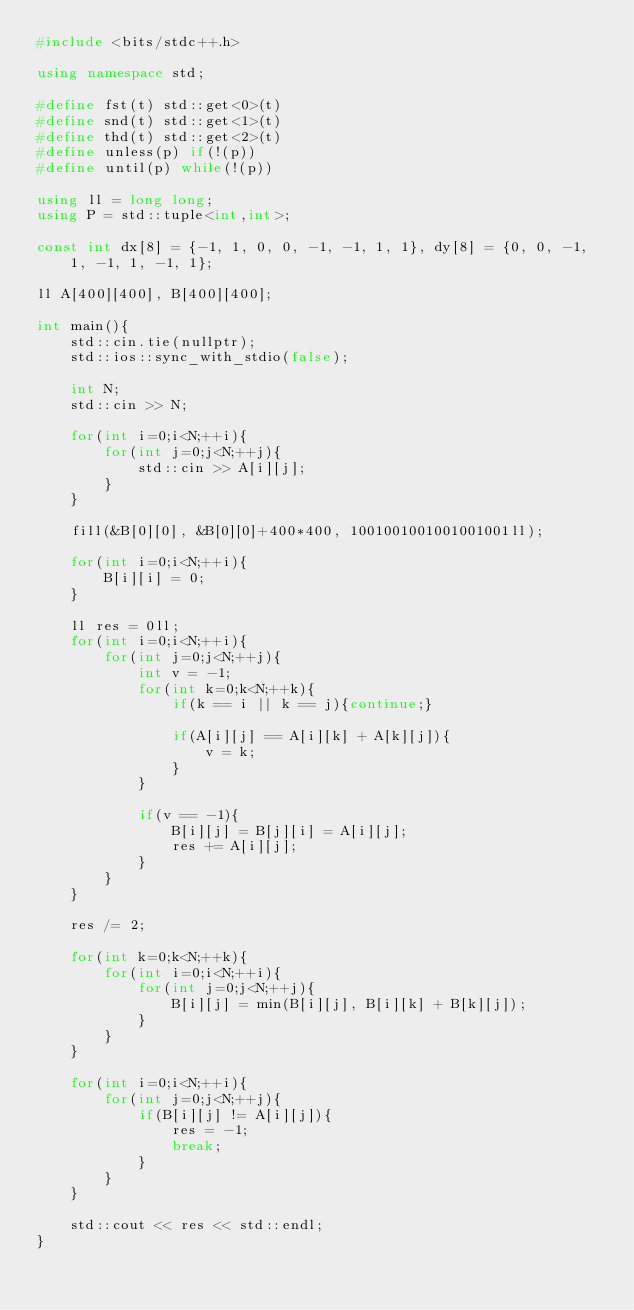Convert code to text. <code><loc_0><loc_0><loc_500><loc_500><_C++_>#include <bits/stdc++.h>

using namespace std;

#define fst(t) std::get<0>(t)
#define snd(t) std::get<1>(t)
#define thd(t) std::get<2>(t)
#define unless(p) if(!(p))
#define until(p) while(!(p))

using ll = long long;
using P = std::tuple<int,int>;

const int dx[8] = {-1, 1, 0, 0, -1, -1, 1, 1}, dy[8] = {0, 0, -1, 1, -1, 1, -1, 1};

ll A[400][400], B[400][400];

int main(){
    std::cin.tie(nullptr);
    std::ios::sync_with_stdio(false);

    int N;
    std::cin >> N;

    for(int i=0;i<N;++i){
        for(int j=0;j<N;++j){
            std::cin >> A[i][j];
        }
    }

    fill(&B[0][0], &B[0][0]+400*400, 1001001001001001001ll);

    for(int i=0;i<N;++i){
        B[i][i] = 0;
    }

    ll res = 0ll;
    for(int i=0;i<N;++i){
        for(int j=0;j<N;++j){
            int v = -1;
            for(int k=0;k<N;++k){
                if(k == i || k == j){continue;}

                if(A[i][j] == A[i][k] + A[k][j]){
                    v = k;
                }
            }

            if(v == -1){
                B[i][j] = B[j][i] = A[i][j];
                res += A[i][j];
            }
        }
    }

    res /= 2;
    
    for(int k=0;k<N;++k){
        for(int i=0;i<N;++i){
            for(int j=0;j<N;++j){
                B[i][j] = min(B[i][j], B[i][k] + B[k][j]);
            }
        }
    }

    for(int i=0;i<N;++i){
        for(int j=0;j<N;++j){
            if(B[i][j] != A[i][j]){
                res = -1;
                break;
            }
        }
    }

    std::cout << res << std::endl;
}
</code> 